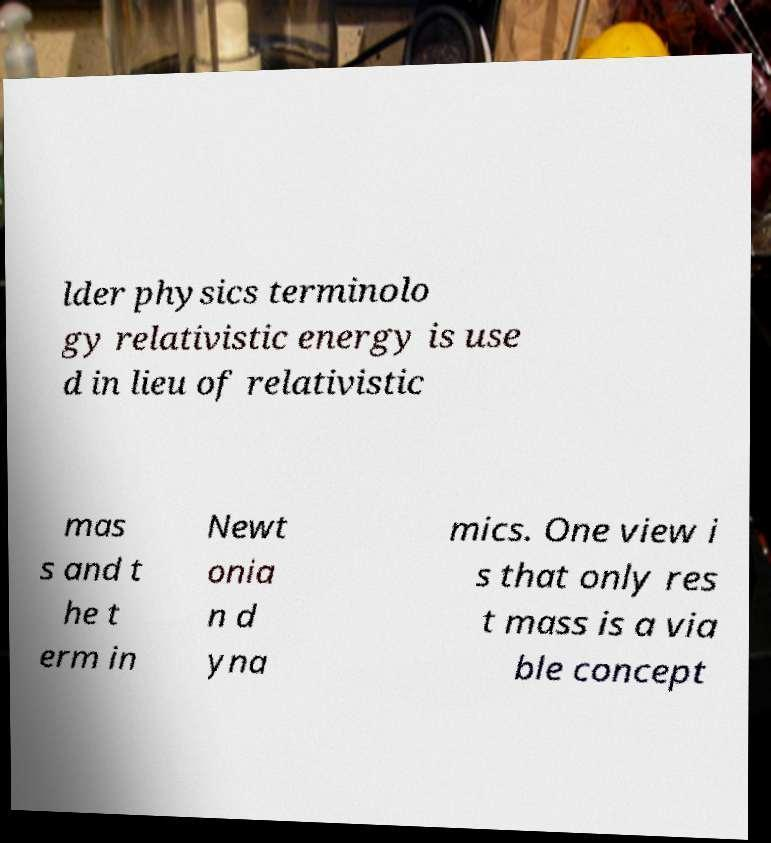What messages or text are displayed in this image? I need them in a readable, typed format. lder physics terminolo gy relativistic energy is use d in lieu of relativistic mas s and t he t erm in Newt onia n d yna mics. One view i s that only res t mass is a via ble concept 